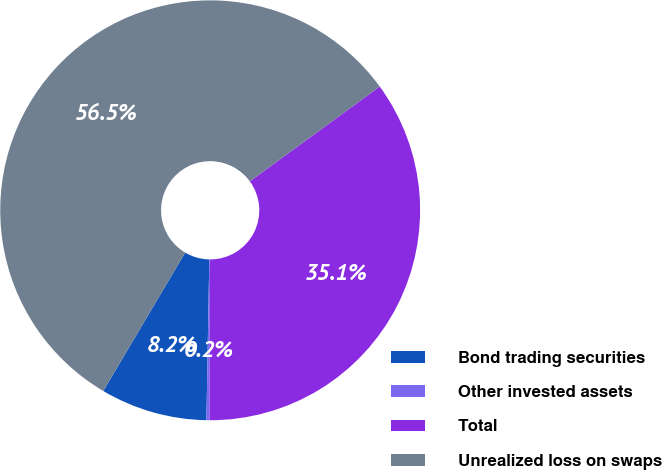Convert chart. <chart><loc_0><loc_0><loc_500><loc_500><pie_chart><fcel>Bond trading securities<fcel>Other invested assets<fcel>Total<fcel>Unrealized loss on swaps<nl><fcel>8.22%<fcel>0.24%<fcel>35.08%<fcel>56.46%<nl></chart> 